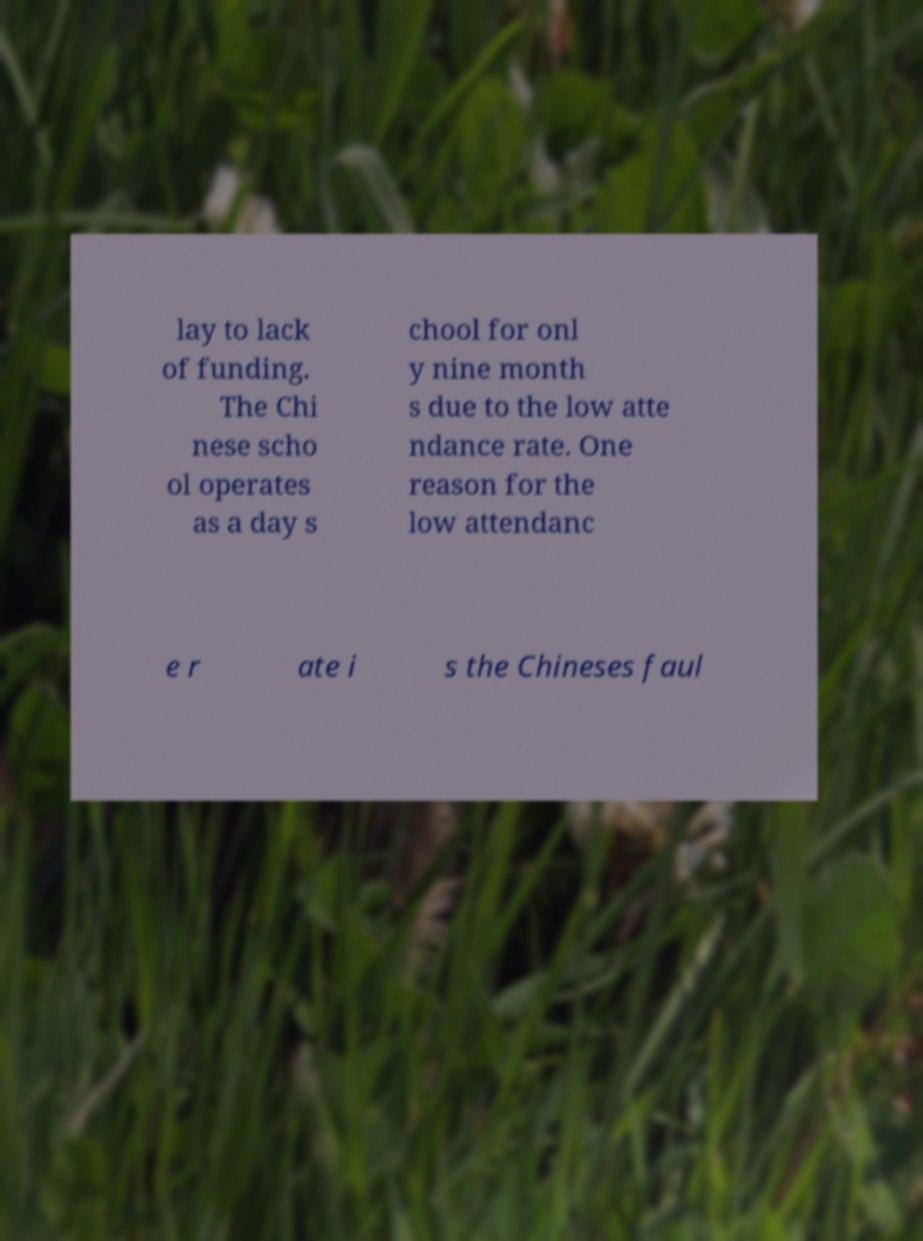Please identify and transcribe the text found in this image. lay to lack of funding. The Chi nese scho ol operates as a day s chool for onl y nine month s due to the low atte ndance rate. One reason for the low attendanc e r ate i s the Chineses faul 